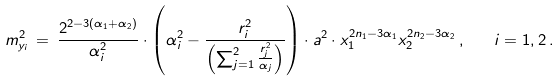<formula> <loc_0><loc_0><loc_500><loc_500>m _ { y _ { i } } ^ { 2 } \, = \, \frac { 2 ^ { 2 - 3 ( \alpha _ { 1 } + \alpha _ { 2 } ) } } { \alpha _ { i } ^ { 2 } } \cdot \left ( \alpha _ { i } ^ { 2 } - \frac { r _ { i } ^ { 2 } } { \left ( \sum _ { j = 1 } ^ { 2 } \frac { r _ { j } ^ { 2 } } { \alpha _ { j } } \right ) } \right ) \cdot a ^ { 2 } \cdot x _ { 1 } ^ { 2 n _ { 1 } - 3 \alpha _ { 1 } } x _ { 2 } ^ { 2 n _ { 2 } - 3 \alpha _ { 2 } } \, , \quad i = 1 , 2 \, .</formula> 